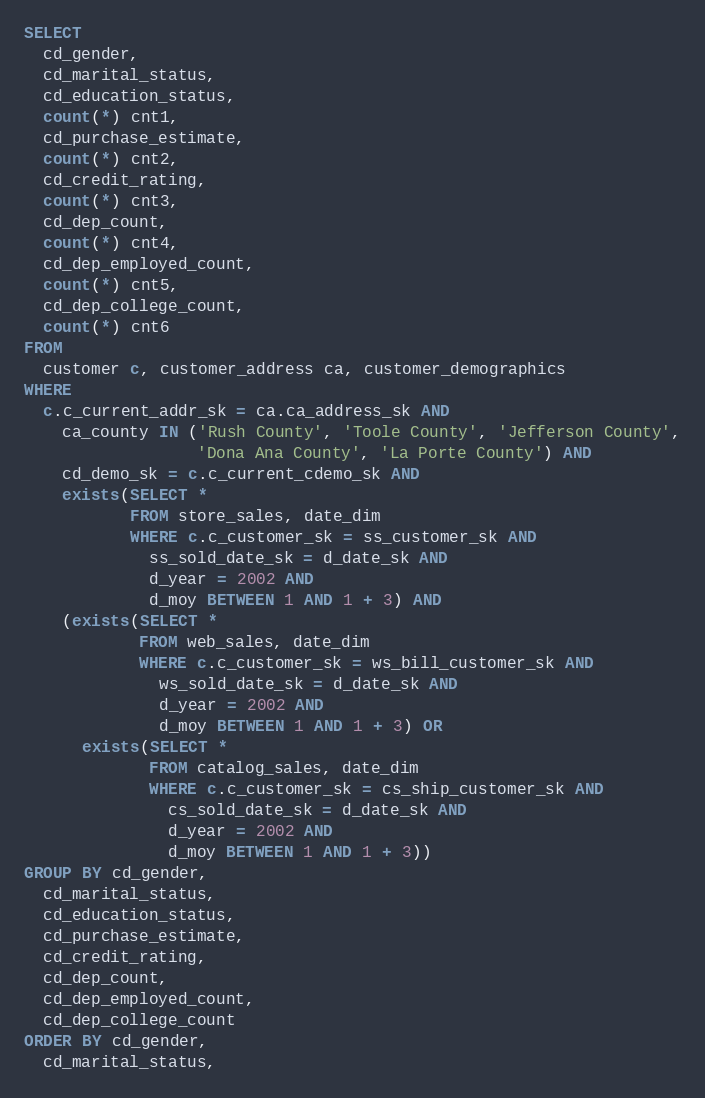<code> <loc_0><loc_0><loc_500><loc_500><_SQL_>SELECT
  cd_gender,
  cd_marital_status,
  cd_education_status,
  count(*) cnt1,
  cd_purchase_estimate,
  count(*) cnt2,
  cd_credit_rating,
  count(*) cnt3,
  cd_dep_count,
  count(*) cnt4,
  cd_dep_employed_count,
  count(*) cnt5,
  cd_dep_college_count,
  count(*) cnt6
FROM
  customer c, customer_address ca, customer_demographics
WHERE
  c.c_current_addr_sk = ca.ca_address_sk AND
    ca_county IN ('Rush County', 'Toole County', 'Jefferson County',
                  'Dona Ana County', 'La Porte County') AND
    cd_demo_sk = c.c_current_cdemo_sk AND
    exists(SELECT *
           FROM store_sales, date_dim
           WHERE c.c_customer_sk = ss_customer_sk AND
             ss_sold_date_sk = d_date_sk AND
             d_year = 2002 AND
             d_moy BETWEEN 1 AND 1 + 3) AND
    (exists(SELECT *
            FROM web_sales, date_dim
            WHERE c.c_customer_sk = ws_bill_customer_sk AND
              ws_sold_date_sk = d_date_sk AND
              d_year = 2002 AND
              d_moy BETWEEN 1 AND 1 + 3) OR
      exists(SELECT *
             FROM catalog_sales, date_dim
             WHERE c.c_customer_sk = cs_ship_customer_sk AND
               cs_sold_date_sk = d_date_sk AND
               d_year = 2002 AND
               d_moy BETWEEN 1 AND 1 + 3))
GROUP BY cd_gender,
  cd_marital_status,
  cd_education_status,
  cd_purchase_estimate,
  cd_credit_rating,
  cd_dep_count,
  cd_dep_employed_count,
  cd_dep_college_count
ORDER BY cd_gender,
  cd_marital_status,</code> 